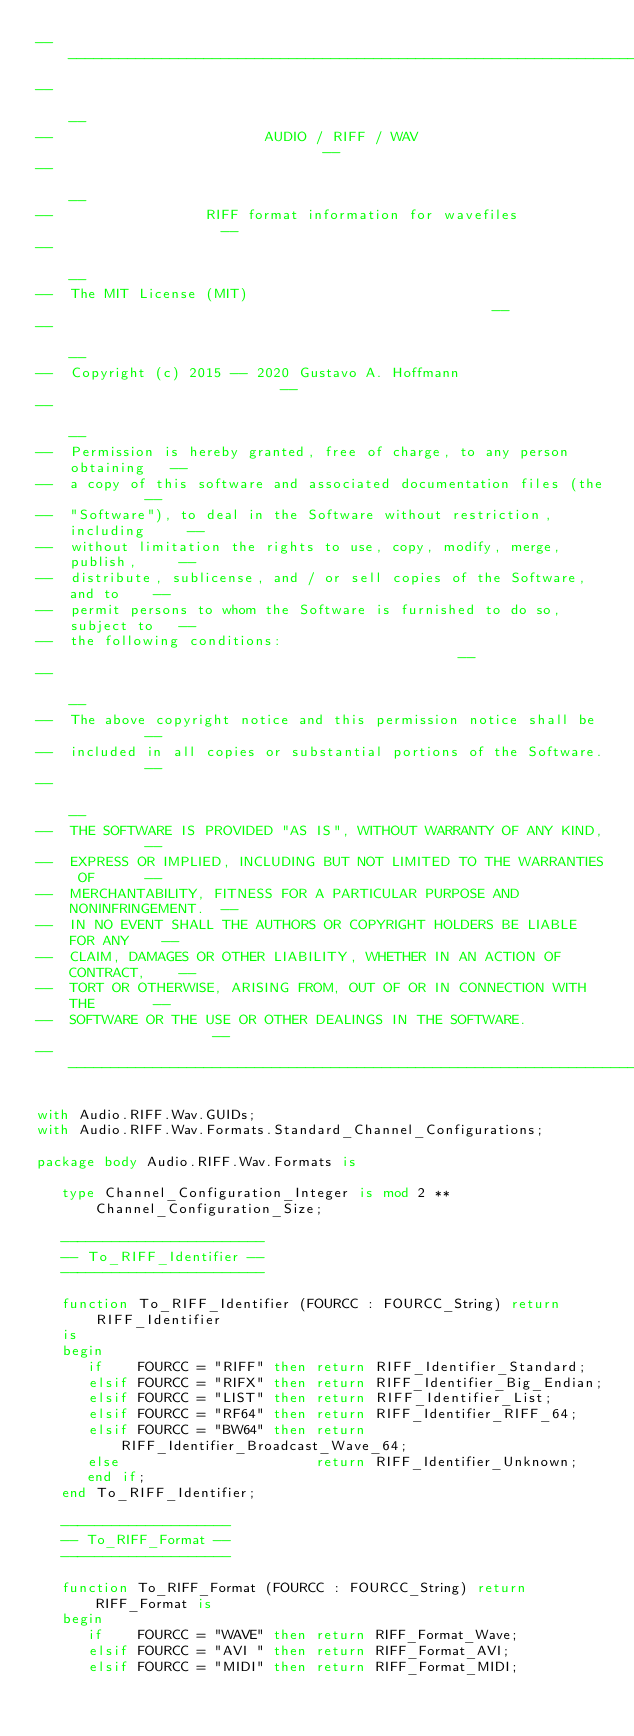Convert code to text. <code><loc_0><loc_0><loc_500><loc_500><_Ada_>------------------------------------------------------------------------------
--                                                                          --
--                         AUDIO / RIFF / WAV                               --
--                                                                          --
--                  RIFF format information for wavefiles                   --
--                                                                          --
--  The MIT License (MIT)                                                   --
--                                                                          --
--  Copyright (c) 2015 -- 2020 Gustavo A. Hoffmann                          --
--                                                                          --
--  Permission is hereby granted, free of charge, to any person obtaining   --
--  a copy of this software and associated documentation files (the         --
--  "Software"), to deal in the Software without restriction, including     --
--  without limitation the rights to use, copy, modify, merge, publish,     --
--  distribute, sublicense, and / or sell copies of the Software, and to    --
--  permit persons to whom the Software is furnished to do so, subject to   --
--  the following conditions:                                               --
--                                                                          --
--  The above copyright notice and this permission notice shall be          --
--  included in all copies or substantial portions of the Software.         --
--                                                                          --
--  THE SOFTWARE IS PROVIDED "AS IS", WITHOUT WARRANTY OF ANY KIND,         --
--  EXPRESS OR IMPLIED, INCLUDING BUT NOT LIMITED TO THE WARRANTIES OF      --
--  MERCHANTABILITY, FITNESS FOR A PARTICULAR PURPOSE AND NONINFRINGEMENT.  --
--  IN NO EVENT SHALL THE AUTHORS OR COPYRIGHT HOLDERS BE LIABLE FOR ANY    --
--  CLAIM, DAMAGES OR OTHER LIABILITY, WHETHER IN AN ACTION OF CONTRACT,    --
--  TORT OR OTHERWISE, ARISING FROM, OUT OF OR IN CONNECTION WITH THE       --
--  SOFTWARE OR THE USE OR OTHER DEALINGS IN THE SOFTWARE.                  --
------------------------------------------------------------------------------

with Audio.RIFF.Wav.GUIDs;
with Audio.RIFF.Wav.Formats.Standard_Channel_Configurations;

package body Audio.RIFF.Wav.Formats is

   type Channel_Configuration_Integer is mod 2 ** Channel_Configuration_Size;

   ------------------------
   -- To_RIFF_Identifier --
   ------------------------

   function To_RIFF_Identifier (FOURCC : FOURCC_String) return RIFF_Identifier
   is
   begin
      if    FOURCC = "RIFF" then return RIFF_Identifier_Standard;
      elsif FOURCC = "RIFX" then return RIFF_Identifier_Big_Endian;
      elsif FOURCC = "LIST" then return RIFF_Identifier_List;
      elsif FOURCC = "RF64" then return RIFF_Identifier_RIFF_64;
      elsif FOURCC = "BW64" then return RIFF_Identifier_Broadcast_Wave_64;
      else                       return RIFF_Identifier_Unknown;
      end if;
   end To_RIFF_Identifier;

   --------------------
   -- To_RIFF_Format --
   --------------------

   function To_RIFF_Format (FOURCC : FOURCC_String) return RIFF_Format is
   begin
      if    FOURCC = "WAVE" then return RIFF_Format_Wave;
      elsif FOURCC = "AVI " then return RIFF_Format_AVI;
      elsif FOURCC = "MIDI" then return RIFF_Format_MIDI;</code> 